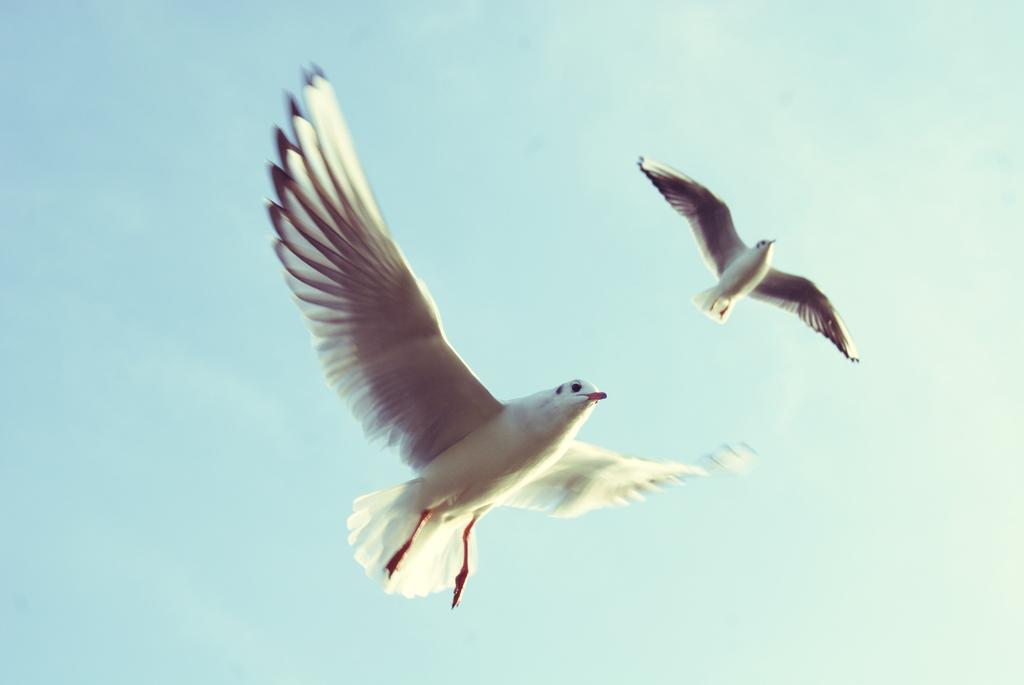How many birds are present in the image? There are two birds in the image. What are the birds doing in the image? The birds are flying in the sky. What type of waves can be seen crashing on the shore in the image? There are no waves or shore present in the image; it features two birds flying in the sky. How many chairs are visible in the image? There are no chairs present in the image; it features two birds flying in the sky. 